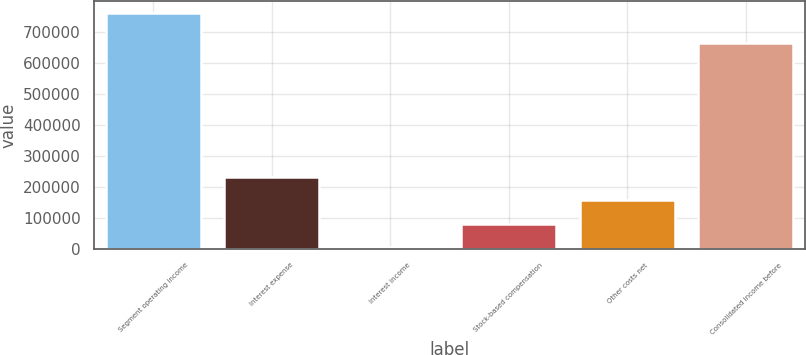Convert chart. <chart><loc_0><loc_0><loc_500><loc_500><bar_chart><fcel>Segment operating income<fcel>Interest expense<fcel>Interest income<fcel>Stock-based compensation<fcel>Other costs net<fcel>Consolidated income before<nl><fcel>761418<fcel>231958<fcel>5046<fcel>80683.2<fcel>156320<fcel>663688<nl></chart> 